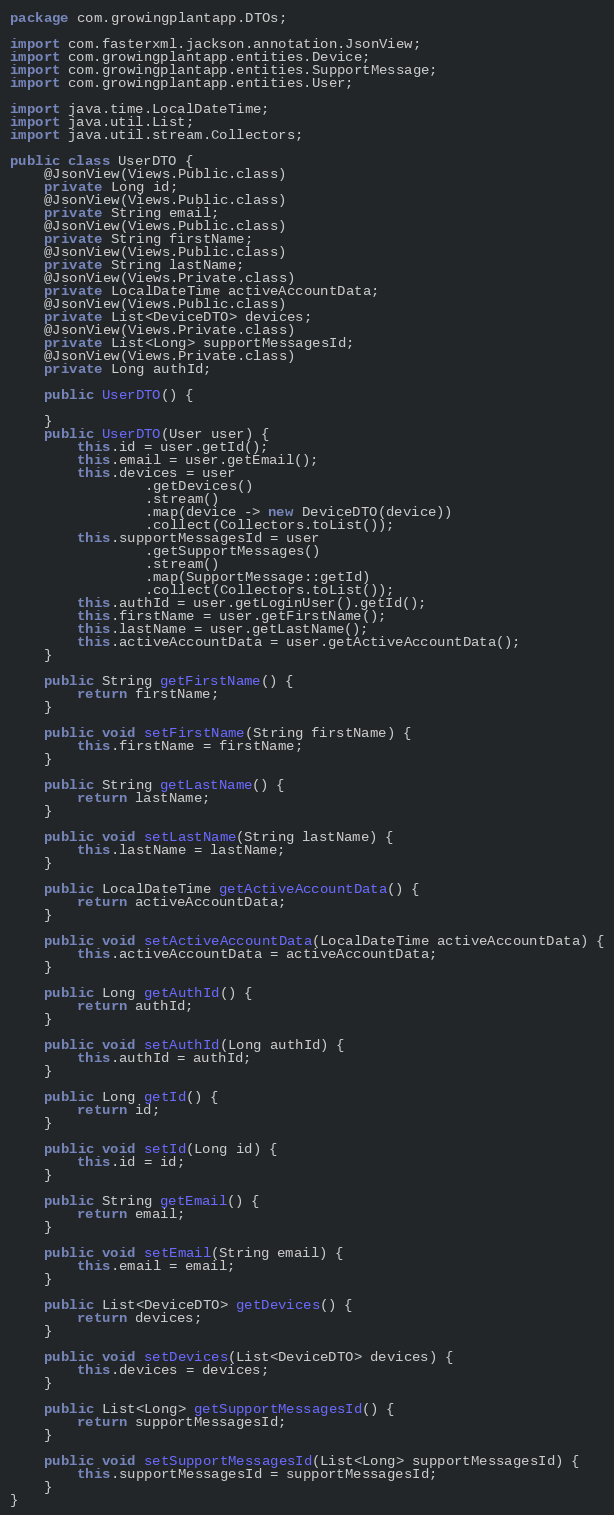<code> <loc_0><loc_0><loc_500><loc_500><_Java_>package com.growingplantapp.DTOs;

import com.fasterxml.jackson.annotation.JsonView;
import com.growingplantapp.entities.Device;
import com.growingplantapp.entities.SupportMessage;
import com.growingplantapp.entities.User;

import java.time.LocalDateTime;
import java.util.List;
import java.util.stream.Collectors;

public class UserDTO {
    @JsonView(Views.Public.class)
    private Long id;
    @JsonView(Views.Public.class)
    private String email;
    @JsonView(Views.Public.class)
    private String firstName;
    @JsonView(Views.Public.class)
    private String lastName;
    @JsonView(Views.Private.class)
    private LocalDateTime activeAccountData;
    @JsonView(Views.Public.class)
    private List<DeviceDTO> devices;
    @JsonView(Views.Private.class)
    private List<Long> supportMessagesId;
    @JsonView(Views.Private.class)
    private Long authId;

    public UserDTO() {

    }
    public UserDTO(User user) {
        this.id = user.getId();
        this.email = user.getEmail();
        this.devices = user
                .getDevices()
                .stream()
                .map(device -> new DeviceDTO(device))
                .collect(Collectors.toList());
        this.supportMessagesId = user
                .getSupportMessages()
                .stream()
                .map(SupportMessage::getId)
                .collect(Collectors.toList());
        this.authId = user.getLoginUser().getId();
        this.firstName = user.getFirstName();
        this.lastName = user.getLastName();
        this.activeAccountData = user.getActiveAccountData();
    }

    public String getFirstName() {
        return firstName;
    }

    public void setFirstName(String firstName) {
        this.firstName = firstName;
    }

    public String getLastName() {
        return lastName;
    }

    public void setLastName(String lastName) {
        this.lastName = lastName;
    }

    public LocalDateTime getActiveAccountData() {
        return activeAccountData;
    }

    public void setActiveAccountData(LocalDateTime activeAccountData) {
        this.activeAccountData = activeAccountData;
    }

    public Long getAuthId() {
        return authId;
    }

    public void setAuthId(Long authId) {
        this.authId = authId;
    }

    public Long getId() {
        return id;
    }

    public void setId(Long id) {
        this.id = id;
    }

    public String getEmail() {
        return email;
    }

    public void setEmail(String email) {
        this.email = email;
    }

    public List<DeviceDTO> getDevices() {
        return devices;
    }

    public void setDevices(List<DeviceDTO> devices) {
        this.devices = devices;
    }

    public List<Long> getSupportMessagesId() {
        return supportMessagesId;
    }

    public void setSupportMessagesId(List<Long> supportMessagesId) {
        this.supportMessagesId = supportMessagesId;
    }
}
</code> 